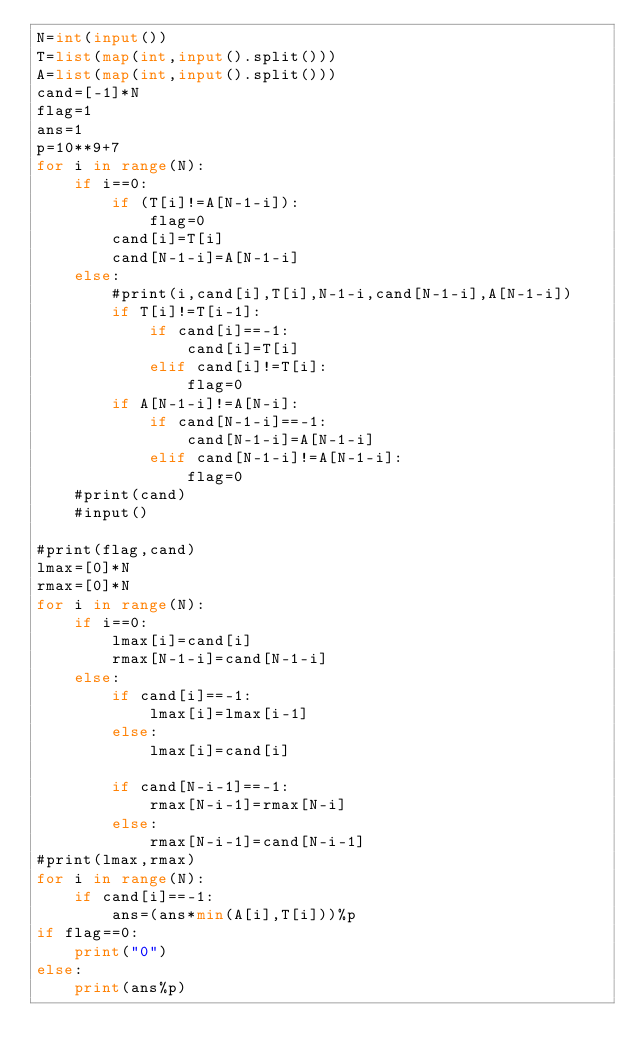<code> <loc_0><loc_0><loc_500><loc_500><_Python_>N=int(input())
T=list(map(int,input().split()))
A=list(map(int,input().split()))
cand=[-1]*N
flag=1
ans=1
p=10**9+7
for i in range(N):
    if i==0:
        if (T[i]!=A[N-1-i]):
            flag=0
        cand[i]=T[i]
        cand[N-1-i]=A[N-1-i]
    else:
        #print(i,cand[i],T[i],N-1-i,cand[N-1-i],A[N-1-i])
        if T[i]!=T[i-1]:
            if cand[i]==-1:
                cand[i]=T[i]
            elif cand[i]!=T[i]:
                flag=0
        if A[N-1-i]!=A[N-i]:
            if cand[N-1-i]==-1:
                cand[N-1-i]=A[N-1-i]
            elif cand[N-1-i]!=A[N-1-i]:
                flag=0
    #print(cand)
    #input()

#print(flag,cand)
lmax=[0]*N
rmax=[0]*N
for i in range(N):
    if i==0:
        lmax[i]=cand[i]
        rmax[N-1-i]=cand[N-1-i]
    else:
        if cand[i]==-1:
            lmax[i]=lmax[i-1]
        else:
            lmax[i]=cand[i]

        if cand[N-i-1]==-1:
            rmax[N-i-1]=rmax[N-i]
        else:
            rmax[N-i-1]=cand[N-i-1]
#print(lmax,rmax)
for i in range(N):
    if cand[i]==-1:
        ans=(ans*min(A[i],T[i]))%p
if flag==0:
    print("0")
else:
    print(ans%p)</code> 